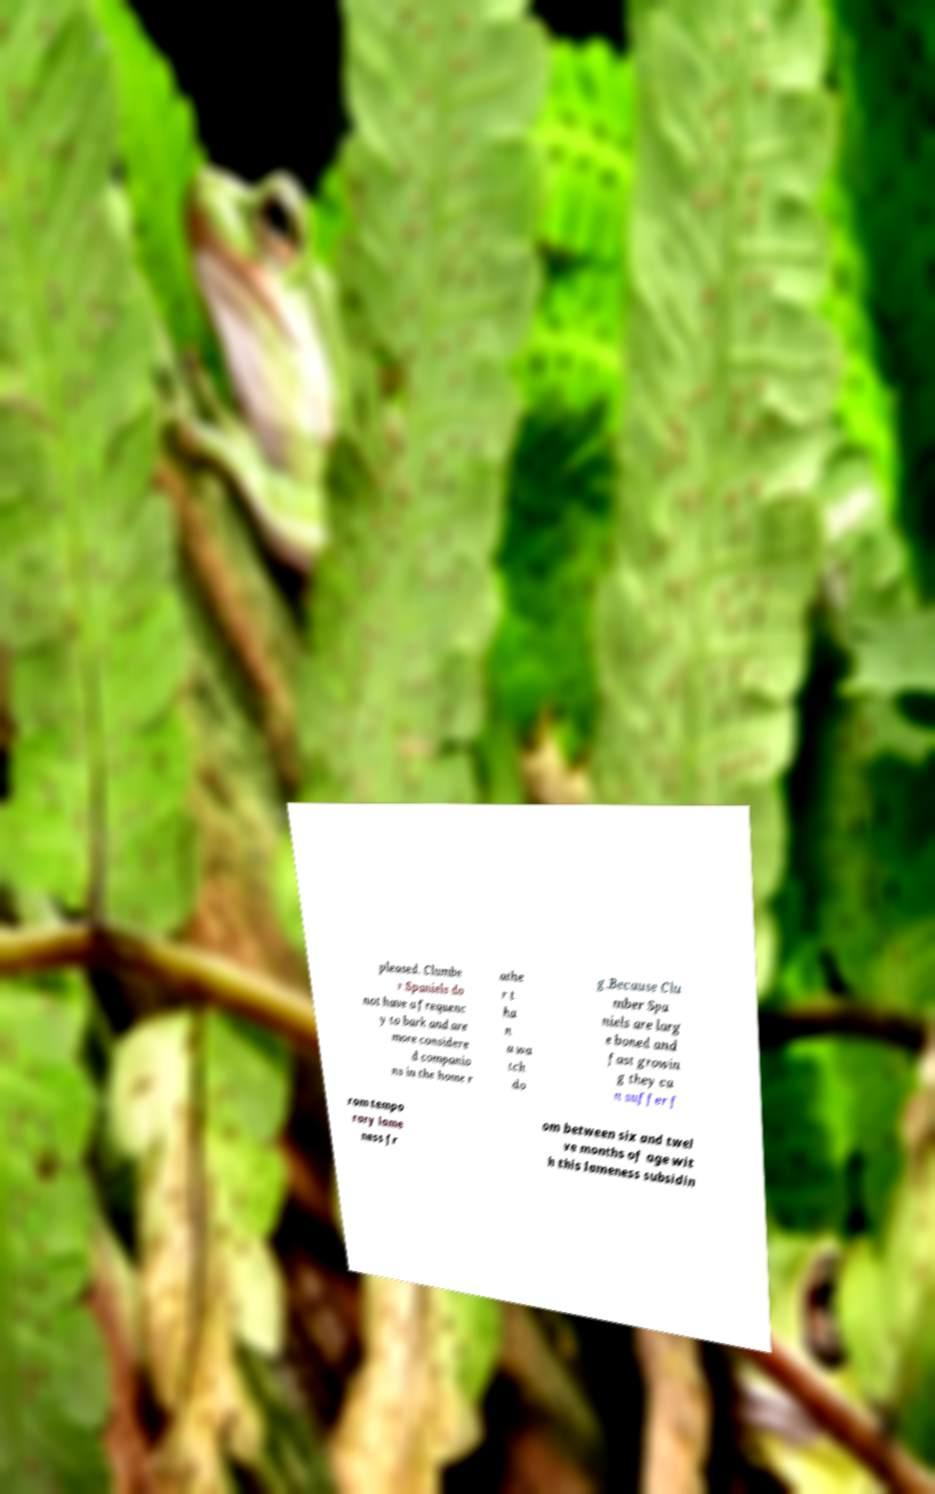For documentation purposes, I need the text within this image transcribed. Could you provide that? pleased. Clumbe r Spaniels do not have a frequenc y to bark and are more considere d companio ns in the home r athe r t ha n a wa tch do g.Because Clu mber Spa niels are larg e boned and fast growin g they ca n suffer f rom tempo rary lame ness fr om between six and twel ve months of age wit h this lameness subsidin 